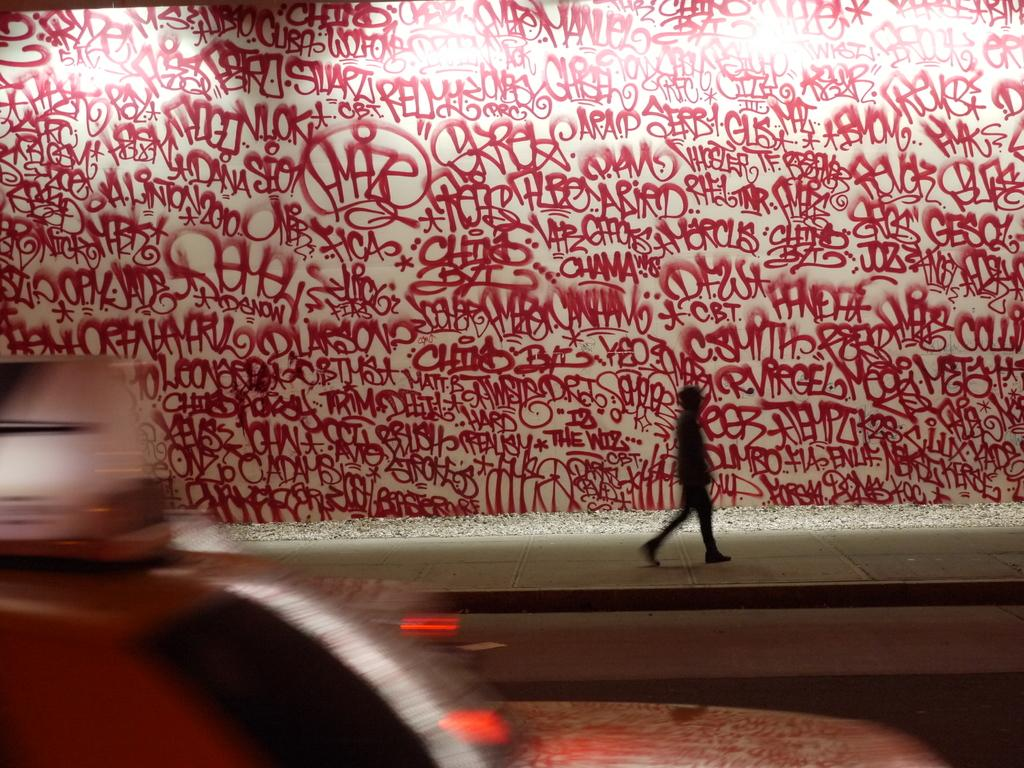What is present on the wall in the image? There is text written on the wall in the image. What type of cherry is growing on the ground in the image? There is no cherry or ground present in the image; it only features text written on the wall. 